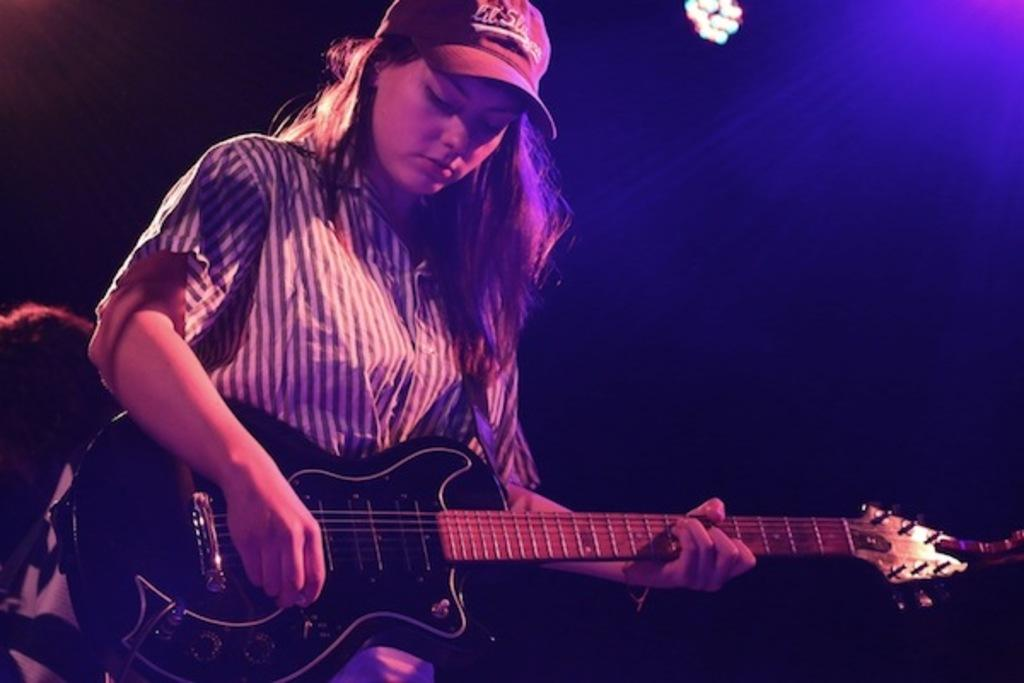What type of event is taking place in the image? The image is from a musical concert. What instrument is the lady playing in the image? The lady is playing a guitar in the image. Can you describe the lady's attire in the image? The lady is wearing a cap in the image. What can be seen in the background of the image? There are lights fitted to the roof in the background. What type of cheese is being served on the street in the image? There is no cheese or street present in the image; it is a musical concert with a lady playing a guitar. 